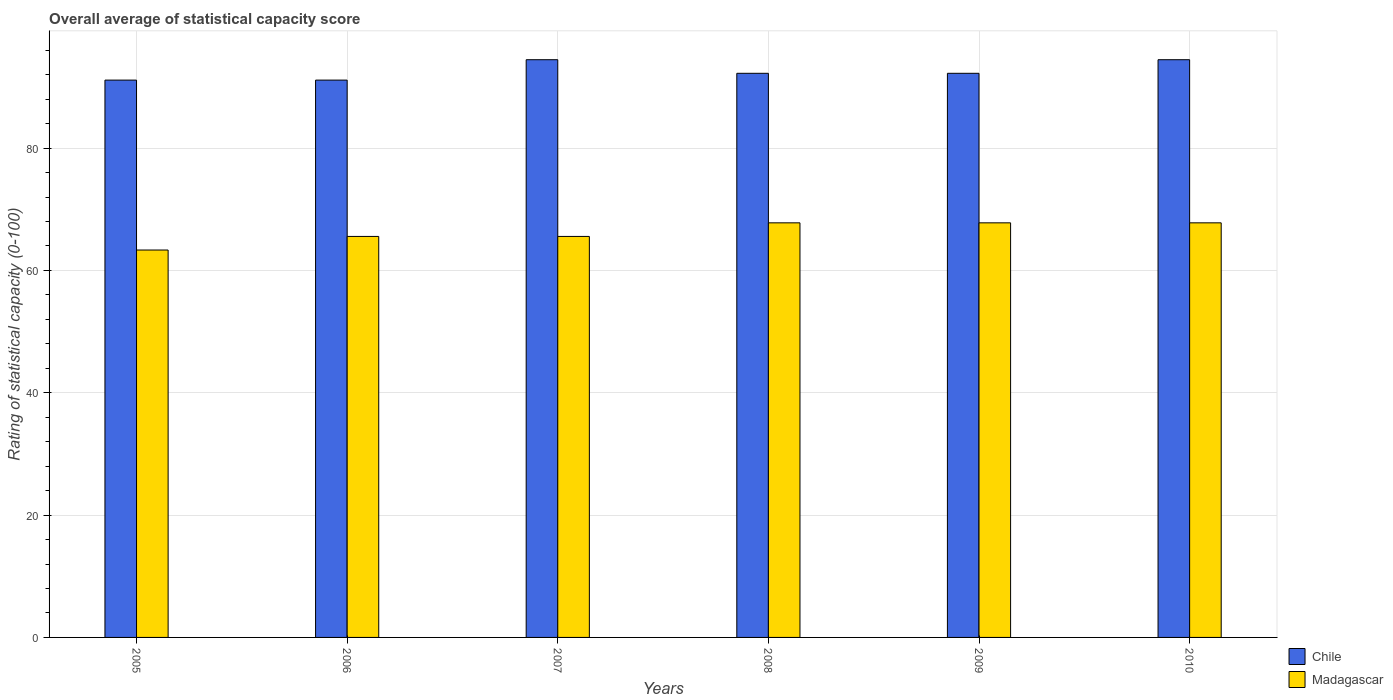How many groups of bars are there?
Your answer should be compact. 6. Are the number of bars per tick equal to the number of legend labels?
Ensure brevity in your answer.  Yes. How many bars are there on the 2nd tick from the right?
Your response must be concise. 2. What is the label of the 2nd group of bars from the left?
Your answer should be very brief. 2006. What is the rating of statistical capacity in Madagascar in 2010?
Make the answer very short. 67.78. Across all years, what is the maximum rating of statistical capacity in Madagascar?
Ensure brevity in your answer.  67.78. Across all years, what is the minimum rating of statistical capacity in Chile?
Give a very brief answer. 91.11. In which year was the rating of statistical capacity in Chile minimum?
Offer a very short reply. 2005. What is the total rating of statistical capacity in Madagascar in the graph?
Offer a terse response. 397.78. What is the difference between the rating of statistical capacity in Chile in 2008 and that in 2009?
Offer a terse response. 0. What is the difference between the rating of statistical capacity in Madagascar in 2010 and the rating of statistical capacity in Chile in 2005?
Provide a short and direct response. -23.33. What is the average rating of statistical capacity in Chile per year?
Offer a terse response. 92.59. In the year 2009, what is the difference between the rating of statistical capacity in Chile and rating of statistical capacity in Madagascar?
Your answer should be compact. 24.44. In how many years, is the rating of statistical capacity in Madagascar greater than 20?
Your response must be concise. 6. What is the ratio of the rating of statistical capacity in Chile in 2006 to that in 2008?
Provide a short and direct response. 0.99. Is the rating of statistical capacity in Chile in 2008 less than that in 2009?
Offer a very short reply. No. Is the difference between the rating of statistical capacity in Chile in 2006 and 2009 greater than the difference between the rating of statistical capacity in Madagascar in 2006 and 2009?
Offer a terse response. Yes. What is the difference between the highest and the second highest rating of statistical capacity in Madagascar?
Provide a short and direct response. 0. What is the difference between the highest and the lowest rating of statistical capacity in Madagascar?
Make the answer very short. 4.44. Is the sum of the rating of statistical capacity in Chile in 2005 and 2010 greater than the maximum rating of statistical capacity in Madagascar across all years?
Offer a terse response. Yes. What does the 1st bar from the left in 2008 represents?
Your answer should be compact. Chile. What does the 1st bar from the right in 2006 represents?
Your answer should be very brief. Madagascar. What is the difference between two consecutive major ticks on the Y-axis?
Offer a very short reply. 20. Does the graph contain any zero values?
Make the answer very short. No. Does the graph contain grids?
Offer a terse response. Yes. Where does the legend appear in the graph?
Ensure brevity in your answer.  Bottom right. How many legend labels are there?
Offer a terse response. 2. How are the legend labels stacked?
Give a very brief answer. Vertical. What is the title of the graph?
Offer a very short reply. Overall average of statistical capacity score. Does "Philippines" appear as one of the legend labels in the graph?
Provide a succinct answer. No. What is the label or title of the X-axis?
Ensure brevity in your answer.  Years. What is the label or title of the Y-axis?
Ensure brevity in your answer.  Rating of statistical capacity (0-100). What is the Rating of statistical capacity (0-100) of Chile in 2005?
Keep it short and to the point. 91.11. What is the Rating of statistical capacity (0-100) in Madagascar in 2005?
Offer a terse response. 63.33. What is the Rating of statistical capacity (0-100) of Chile in 2006?
Keep it short and to the point. 91.11. What is the Rating of statistical capacity (0-100) in Madagascar in 2006?
Keep it short and to the point. 65.56. What is the Rating of statistical capacity (0-100) of Chile in 2007?
Offer a terse response. 94.44. What is the Rating of statistical capacity (0-100) in Madagascar in 2007?
Your answer should be compact. 65.56. What is the Rating of statistical capacity (0-100) in Chile in 2008?
Give a very brief answer. 92.22. What is the Rating of statistical capacity (0-100) of Madagascar in 2008?
Your answer should be compact. 67.78. What is the Rating of statistical capacity (0-100) in Chile in 2009?
Offer a terse response. 92.22. What is the Rating of statistical capacity (0-100) in Madagascar in 2009?
Offer a terse response. 67.78. What is the Rating of statistical capacity (0-100) in Chile in 2010?
Provide a short and direct response. 94.44. What is the Rating of statistical capacity (0-100) in Madagascar in 2010?
Provide a short and direct response. 67.78. Across all years, what is the maximum Rating of statistical capacity (0-100) in Chile?
Offer a very short reply. 94.44. Across all years, what is the maximum Rating of statistical capacity (0-100) in Madagascar?
Ensure brevity in your answer.  67.78. Across all years, what is the minimum Rating of statistical capacity (0-100) of Chile?
Ensure brevity in your answer.  91.11. Across all years, what is the minimum Rating of statistical capacity (0-100) of Madagascar?
Provide a short and direct response. 63.33. What is the total Rating of statistical capacity (0-100) of Chile in the graph?
Your response must be concise. 555.56. What is the total Rating of statistical capacity (0-100) in Madagascar in the graph?
Provide a short and direct response. 397.78. What is the difference between the Rating of statistical capacity (0-100) in Madagascar in 2005 and that in 2006?
Ensure brevity in your answer.  -2.22. What is the difference between the Rating of statistical capacity (0-100) of Madagascar in 2005 and that in 2007?
Offer a very short reply. -2.22. What is the difference between the Rating of statistical capacity (0-100) in Chile in 2005 and that in 2008?
Make the answer very short. -1.11. What is the difference between the Rating of statistical capacity (0-100) of Madagascar in 2005 and that in 2008?
Keep it short and to the point. -4.44. What is the difference between the Rating of statistical capacity (0-100) in Chile in 2005 and that in 2009?
Your answer should be very brief. -1.11. What is the difference between the Rating of statistical capacity (0-100) in Madagascar in 2005 and that in 2009?
Your answer should be very brief. -4.44. What is the difference between the Rating of statistical capacity (0-100) in Chile in 2005 and that in 2010?
Your answer should be compact. -3.33. What is the difference between the Rating of statistical capacity (0-100) in Madagascar in 2005 and that in 2010?
Ensure brevity in your answer.  -4.44. What is the difference between the Rating of statistical capacity (0-100) of Chile in 2006 and that in 2007?
Provide a short and direct response. -3.33. What is the difference between the Rating of statistical capacity (0-100) in Madagascar in 2006 and that in 2007?
Give a very brief answer. 0. What is the difference between the Rating of statistical capacity (0-100) of Chile in 2006 and that in 2008?
Keep it short and to the point. -1.11. What is the difference between the Rating of statistical capacity (0-100) of Madagascar in 2006 and that in 2008?
Make the answer very short. -2.22. What is the difference between the Rating of statistical capacity (0-100) in Chile in 2006 and that in 2009?
Your answer should be compact. -1.11. What is the difference between the Rating of statistical capacity (0-100) of Madagascar in 2006 and that in 2009?
Ensure brevity in your answer.  -2.22. What is the difference between the Rating of statistical capacity (0-100) of Madagascar in 2006 and that in 2010?
Your response must be concise. -2.22. What is the difference between the Rating of statistical capacity (0-100) in Chile in 2007 and that in 2008?
Provide a short and direct response. 2.22. What is the difference between the Rating of statistical capacity (0-100) of Madagascar in 2007 and that in 2008?
Your response must be concise. -2.22. What is the difference between the Rating of statistical capacity (0-100) in Chile in 2007 and that in 2009?
Your answer should be very brief. 2.22. What is the difference between the Rating of statistical capacity (0-100) in Madagascar in 2007 and that in 2009?
Offer a very short reply. -2.22. What is the difference between the Rating of statistical capacity (0-100) of Chile in 2007 and that in 2010?
Ensure brevity in your answer.  0. What is the difference between the Rating of statistical capacity (0-100) of Madagascar in 2007 and that in 2010?
Offer a terse response. -2.22. What is the difference between the Rating of statistical capacity (0-100) of Chile in 2008 and that in 2010?
Make the answer very short. -2.22. What is the difference between the Rating of statistical capacity (0-100) of Chile in 2009 and that in 2010?
Give a very brief answer. -2.22. What is the difference between the Rating of statistical capacity (0-100) of Chile in 2005 and the Rating of statistical capacity (0-100) of Madagascar in 2006?
Give a very brief answer. 25.56. What is the difference between the Rating of statistical capacity (0-100) of Chile in 2005 and the Rating of statistical capacity (0-100) of Madagascar in 2007?
Provide a succinct answer. 25.56. What is the difference between the Rating of statistical capacity (0-100) of Chile in 2005 and the Rating of statistical capacity (0-100) of Madagascar in 2008?
Keep it short and to the point. 23.33. What is the difference between the Rating of statistical capacity (0-100) in Chile in 2005 and the Rating of statistical capacity (0-100) in Madagascar in 2009?
Keep it short and to the point. 23.33. What is the difference between the Rating of statistical capacity (0-100) of Chile in 2005 and the Rating of statistical capacity (0-100) of Madagascar in 2010?
Your response must be concise. 23.33. What is the difference between the Rating of statistical capacity (0-100) of Chile in 2006 and the Rating of statistical capacity (0-100) of Madagascar in 2007?
Your answer should be very brief. 25.56. What is the difference between the Rating of statistical capacity (0-100) in Chile in 2006 and the Rating of statistical capacity (0-100) in Madagascar in 2008?
Provide a short and direct response. 23.33. What is the difference between the Rating of statistical capacity (0-100) in Chile in 2006 and the Rating of statistical capacity (0-100) in Madagascar in 2009?
Provide a short and direct response. 23.33. What is the difference between the Rating of statistical capacity (0-100) of Chile in 2006 and the Rating of statistical capacity (0-100) of Madagascar in 2010?
Give a very brief answer. 23.33. What is the difference between the Rating of statistical capacity (0-100) of Chile in 2007 and the Rating of statistical capacity (0-100) of Madagascar in 2008?
Give a very brief answer. 26.67. What is the difference between the Rating of statistical capacity (0-100) of Chile in 2007 and the Rating of statistical capacity (0-100) of Madagascar in 2009?
Make the answer very short. 26.67. What is the difference between the Rating of statistical capacity (0-100) of Chile in 2007 and the Rating of statistical capacity (0-100) of Madagascar in 2010?
Make the answer very short. 26.67. What is the difference between the Rating of statistical capacity (0-100) in Chile in 2008 and the Rating of statistical capacity (0-100) in Madagascar in 2009?
Keep it short and to the point. 24.44. What is the difference between the Rating of statistical capacity (0-100) of Chile in 2008 and the Rating of statistical capacity (0-100) of Madagascar in 2010?
Keep it short and to the point. 24.44. What is the difference between the Rating of statistical capacity (0-100) of Chile in 2009 and the Rating of statistical capacity (0-100) of Madagascar in 2010?
Your answer should be compact. 24.44. What is the average Rating of statistical capacity (0-100) in Chile per year?
Keep it short and to the point. 92.59. What is the average Rating of statistical capacity (0-100) in Madagascar per year?
Provide a short and direct response. 66.3. In the year 2005, what is the difference between the Rating of statistical capacity (0-100) in Chile and Rating of statistical capacity (0-100) in Madagascar?
Keep it short and to the point. 27.78. In the year 2006, what is the difference between the Rating of statistical capacity (0-100) of Chile and Rating of statistical capacity (0-100) of Madagascar?
Offer a terse response. 25.56. In the year 2007, what is the difference between the Rating of statistical capacity (0-100) in Chile and Rating of statistical capacity (0-100) in Madagascar?
Provide a short and direct response. 28.89. In the year 2008, what is the difference between the Rating of statistical capacity (0-100) in Chile and Rating of statistical capacity (0-100) in Madagascar?
Offer a very short reply. 24.44. In the year 2009, what is the difference between the Rating of statistical capacity (0-100) of Chile and Rating of statistical capacity (0-100) of Madagascar?
Offer a very short reply. 24.44. In the year 2010, what is the difference between the Rating of statistical capacity (0-100) in Chile and Rating of statistical capacity (0-100) in Madagascar?
Your answer should be very brief. 26.67. What is the ratio of the Rating of statistical capacity (0-100) of Chile in 2005 to that in 2006?
Offer a terse response. 1. What is the ratio of the Rating of statistical capacity (0-100) in Madagascar in 2005 to that in 2006?
Your answer should be compact. 0.97. What is the ratio of the Rating of statistical capacity (0-100) in Chile in 2005 to that in 2007?
Provide a succinct answer. 0.96. What is the ratio of the Rating of statistical capacity (0-100) in Madagascar in 2005 to that in 2007?
Your answer should be compact. 0.97. What is the ratio of the Rating of statistical capacity (0-100) in Chile in 2005 to that in 2008?
Make the answer very short. 0.99. What is the ratio of the Rating of statistical capacity (0-100) in Madagascar in 2005 to that in 2008?
Keep it short and to the point. 0.93. What is the ratio of the Rating of statistical capacity (0-100) in Madagascar in 2005 to that in 2009?
Provide a succinct answer. 0.93. What is the ratio of the Rating of statistical capacity (0-100) in Chile in 2005 to that in 2010?
Offer a very short reply. 0.96. What is the ratio of the Rating of statistical capacity (0-100) of Madagascar in 2005 to that in 2010?
Your response must be concise. 0.93. What is the ratio of the Rating of statistical capacity (0-100) of Chile in 2006 to that in 2007?
Provide a succinct answer. 0.96. What is the ratio of the Rating of statistical capacity (0-100) in Madagascar in 2006 to that in 2008?
Provide a short and direct response. 0.97. What is the ratio of the Rating of statistical capacity (0-100) in Chile in 2006 to that in 2009?
Your answer should be very brief. 0.99. What is the ratio of the Rating of statistical capacity (0-100) in Madagascar in 2006 to that in 2009?
Offer a very short reply. 0.97. What is the ratio of the Rating of statistical capacity (0-100) of Chile in 2006 to that in 2010?
Offer a terse response. 0.96. What is the ratio of the Rating of statistical capacity (0-100) in Madagascar in 2006 to that in 2010?
Your answer should be compact. 0.97. What is the ratio of the Rating of statistical capacity (0-100) in Chile in 2007 to that in 2008?
Offer a very short reply. 1.02. What is the ratio of the Rating of statistical capacity (0-100) in Madagascar in 2007 to that in 2008?
Ensure brevity in your answer.  0.97. What is the ratio of the Rating of statistical capacity (0-100) of Chile in 2007 to that in 2009?
Ensure brevity in your answer.  1.02. What is the ratio of the Rating of statistical capacity (0-100) in Madagascar in 2007 to that in 2009?
Provide a short and direct response. 0.97. What is the ratio of the Rating of statistical capacity (0-100) in Chile in 2007 to that in 2010?
Provide a short and direct response. 1. What is the ratio of the Rating of statistical capacity (0-100) in Madagascar in 2007 to that in 2010?
Offer a terse response. 0.97. What is the ratio of the Rating of statistical capacity (0-100) of Chile in 2008 to that in 2009?
Keep it short and to the point. 1. What is the ratio of the Rating of statistical capacity (0-100) in Madagascar in 2008 to that in 2009?
Your answer should be very brief. 1. What is the ratio of the Rating of statistical capacity (0-100) of Chile in 2008 to that in 2010?
Your answer should be very brief. 0.98. What is the ratio of the Rating of statistical capacity (0-100) of Chile in 2009 to that in 2010?
Provide a short and direct response. 0.98. What is the difference between the highest and the lowest Rating of statistical capacity (0-100) of Chile?
Your response must be concise. 3.33. What is the difference between the highest and the lowest Rating of statistical capacity (0-100) in Madagascar?
Offer a terse response. 4.44. 